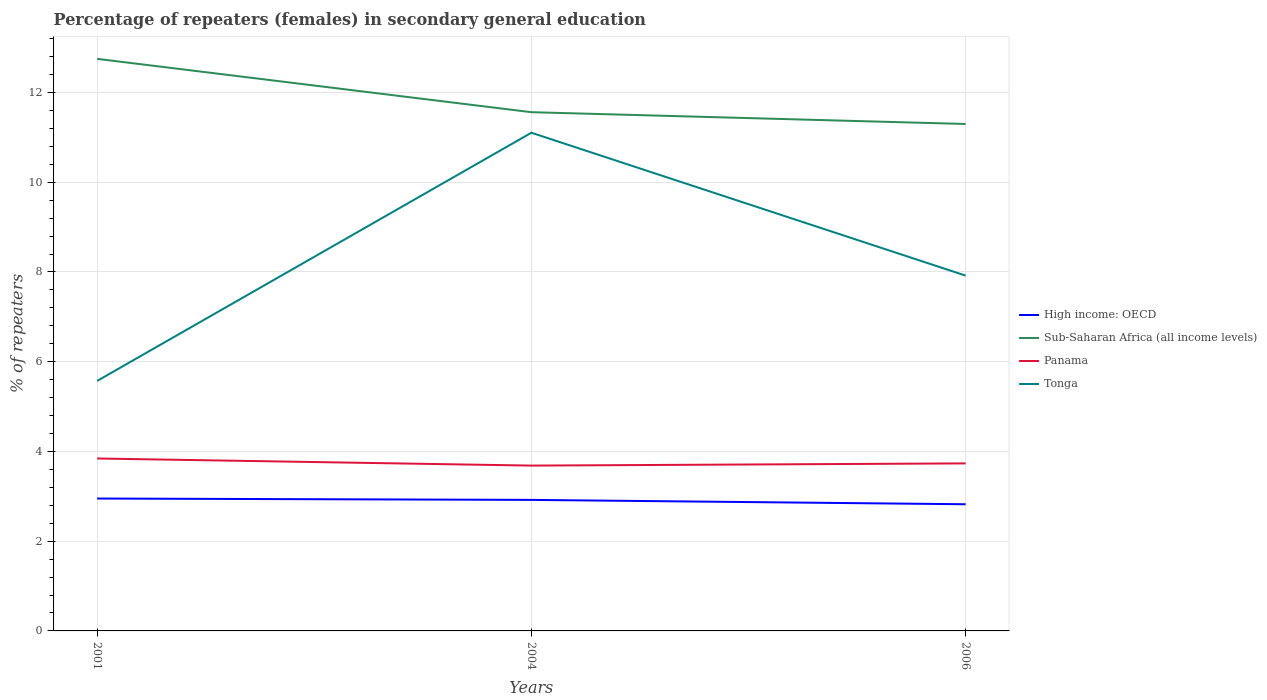How many different coloured lines are there?
Your answer should be very brief. 4. Across all years, what is the maximum percentage of female repeaters in Panama?
Give a very brief answer. 3.68. What is the total percentage of female repeaters in Panama in the graph?
Offer a terse response. -0.05. What is the difference between the highest and the second highest percentage of female repeaters in Panama?
Your answer should be compact. 0.16. What is the difference between the highest and the lowest percentage of female repeaters in High income: OECD?
Ensure brevity in your answer.  2. How many lines are there?
Provide a succinct answer. 4. What is the difference between two consecutive major ticks on the Y-axis?
Offer a terse response. 2. Are the values on the major ticks of Y-axis written in scientific E-notation?
Make the answer very short. No. Does the graph contain grids?
Your answer should be compact. Yes. How are the legend labels stacked?
Ensure brevity in your answer.  Vertical. What is the title of the graph?
Keep it short and to the point. Percentage of repeaters (females) in secondary general education. What is the label or title of the X-axis?
Offer a terse response. Years. What is the label or title of the Y-axis?
Offer a terse response. % of repeaters. What is the % of repeaters in High income: OECD in 2001?
Ensure brevity in your answer.  2.95. What is the % of repeaters in Sub-Saharan Africa (all income levels) in 2001?
Give a very brief answer. 12.75. What is the % of repeaters of Panama in 2001?
Your answer should be very brief. 3.84. What is the % of repeaters in Tonga in 2001?
Your answer should be compact. 5.57. What is the % of repeaters in High income: OECD in 2004?
Give a very brief answer. 2.92. What is the % of repeaters in Sub-Saharan Africa (all income levels) in 2004?
Ensure brevity in your answer.  11.56. What is the % of repeaters of Panama in 2004?
Provide a succinct answer. 3.68. What is the % of repeaters of Tonga in 2004?
Your answer should be very brief. 11.1. What is the % of repeaters of High income: OECD in 2006?
Make the answer very short. 2.82. What is the % of repeaters in Sub-Saharan Africa (all income levels) in 2006?
Provide a short and direct response. 11.3. What is the % of repeaters of Panama in 2006?
Provide a succinct answer. 3.73. What is the % of repeaters of Tonga in 2006?
Offer a very short reply. 7.92. Across all years, what is the maximum % of repeaters in High income: OECD?
Give a very brief answer. 2.95. Across all years, what is the maximum % of repeaters of Sub-Saharan Africa (all income levels)?
Make the answer very short. 12.75. Across all years, what is the maximum % of repeaters in Panama?
Provide a succinct answer. 3.84. Across all years, what is the maximum % of repeaters of Tonga?
Provide a short and direct response. 11.1. Across all years, what is the minimum % of repeaters of High income: OECD?
Offer a terse response. 2.82. Across all years, what is the minimum % of repeaters in Sub-Saharan Africa (all income levels)?
Ensure brevity in your answer.  11.3. Across all years, what is the minimum % of repeaters of Panama?
Your response must be concise. 3.68. Across all years, what is the minimum % of repeaters of Tonga?
Provide a succinct answer. 5.57. What is the total % of repeaters in High income: OECD in the graph?
Offer a terse response. 8.69. What is the total % of repeaters of Sub-Saharan Africa (all income levels) in the graph?
Make the answer very short. 35.61. What is the total % of repeaters of Panama in the graph?
Offer a terse response. 11.26. What is the total % of repeaters of Tonga in the graph?
Offer a very short reply. 24.6. What is the difference between the % of repeaters of High income: OECD in 2001 and that in 2004?
Offer a very short reply. 0.03. What is the difference between the % of repeaters in Sub-Saharan Africa (all income levels) in 2001 and that in 2004?
Ensure brevity in your answer.  1.19. What is the difference between the % of repeaters in Panama in 2001 and that in 2004?
Make the answer very short. 0.16. What is the difference between the % of repeaters in Tonga in 2001 and that in 2004?
Your answer should be compact. -5.53. What is the difference between the % of repeaters of High income: OECD in 2001 and that in 2006?
Offer a terse response. 0.13. What is the difference between the % of repeaters of Sub-Saharan Africa (all income levels) in 2001 and that in 2006?
Give a very brief answer. 1.45. What is the difference between the % of repeaters in Panama in 2001 and that in 2006?
Your answer should be compact. 0.11. What is the difference between the % of repeaters in Tonga in 2001 and that in 2006?
Provide a short and direct response. -2.35. What is the difference between the % of repeaters in High income: OECD in 2004 and that in 2006?
Offer a very short reply. 0.1. What is the difference between the % of repeaters of Sub-Saharan Africa (all income levels) in 2004 and that in 2006?
Provide a succinct answer. 0.26. What is the difference between the % of repeaters in Panama in 2004 and that in 2006?
Your response must be concise. -0.05. What is the difference between the % of repeaters of Tonga in 2004 and that in 2006?
Your answer should be very brief. 3.19. What is the difference between the % of repeaters of High income: OECD in 2001 and the % of repeaters of Sub-Saharan Africa (all income levels) in 2004?
Your answer should be very brief. -8.61. What is the difference between the % of repeaters in High income: OECD in 2001 and the % of repeaters in Panama in 2004?
Offer a very short reply. -0.73. What is the difference between the % of repeaters in High income: OECD in 2001 and the % of repeaters in Tonga in 2004?
Your response must be concise. -8.15. What is the difference between the % of repeaters of Sub-Saharan Africa (all income levels) in 2001 and the % of repeaters of Panama in 2004?
Ensure brevity in your answer.  9.07. What is the difference between the % of repeaters of Sub-Saharan Africa (all income levels) in 2001 and the % of repeaters of Tonga in 2004?
Offer a terse response. 1.65. What is the difference between the % of repeaters in Panama in 2001 and the % of repeaters in Tonga in 2004?
Keep it short and to the point. -7.26. What is the difference between the % of repeaters in High income: OECD in 2001 and the % of repeaters in Sub-Saharan Africa (all income levels) in 2006?
Offer a terse response. -8.35. What is the difference between the % of repeaters in High income: OECD in 2001 and the % of repeaters in Panama in 2006?
Provide a short and direct response. -0.78. What is the difference between the % of repeaters of High income: OECD in 2001 and the % of repeaters of Tonga in 2006?
Keep it short and to the point. -4.97. What is the difference between the % of repeaters of Sub-Saharan Africa (all income levels) in 2001 and the % of repeaters of Panama in 2006?
Provide a short and direct response. 9.02. What is the difference between the % of repeaters of Sub-Saharan Africa (all income levels) in 2001 and the % of repeaters of Tonga in 2006?
Make the answer very short. 4.83. What is the difference between the % of repeaters of Panama in 2001 and the % of repeaters of Tonga in 2006?
Offer a very short reply. -4.08. What is the difference between the % of repeaters of High income: OECD in 2004 and the % of repeaters of Sub-Saharan Africa (all income levels) in 2006?
Your response must be concise. -8.38. What is the difference between the % of repeaters of High income: OECD in 2004 and the % of repeaters of Panama in 2006?
Your answer should be compact. -0.81. What is the difference between the % of repeaters of High income: OECD in 2004 and the % of repeaters of Tonga in 2006?
Make the answer very short. -5. What is the difference between the % of repeaters of Sub-Saharan Africa (all income levels) in 2004 and the % of repeaters of Panama in 2006?
Offer a very short reply. 7.83. What is the difference between the % of repeaters in Sub-Saharan Africa (all income levels) in 2004 and the % of repeaters in Tonga in 2006?
Keep it short and to the point. 3.64. What is the difference between the % of repeaters in Panama in 2004 and the % of repeaters in Tonga in 2006?
Your answer should be very brief. -4.23. What is the average % of repeaters in High income: OECD per year?
Your response must be concise. 2.9. What is the average % of repeaters of Sub-Saharan Africa (all income levels) per year?
Ensure brevity in your answer.  11.87. What is the average % of repeaters of Panama per year?
Your answer should be very brief. 3.75. What is the average % of repeaters in Tonga per year?
Provide a succinct answer. 8.2. In the year 2001, what is the difference between the % of repeaters of High income: OECD and % of repeaters of Sub-Saharan Africa (all income levels)?
Provide a short and direct response. -9.8. In the year 2001, what is the difference between the % of repeaters of High income: OECD and % of repeaters of Panama?
Your answer should be compact. -0.89. In the year 2001, what is the difference between the % of repeaters in High income: OECD and % of repeaters in Tonga?
Make the answer very short. -2.62. In the year 2001, what is the difference between the % of repeaters in Sub-Saharan Africa (all income levels) and % of repeaters in Panama?
Make the answer very short. 8.91. In the year 2001, what is the difference between the % of repeaters in Sub-Saharan Africa (all income levels) and % of repeaters in Tonga?
Your answer should be compact. 7.18. In the year 2001, what is the difference between the % of repeaters of Panama and % of repeaters of Tonga?
Keep it short and to the point. -1.73. In the year 2004, what is the difference between the % of repeaters of High income: OECD and % of repeaters of Sub-Saharan Africa (all income levels)?
Keep it short and to the point. -8.64. In the year 2004, what is the difference between the % of repeaters in High income: OECD and % of repeaters in Panama?
Keep it short and to the point. -0.76. In the year 2004, what is the difference between the % of repeaters of High income: OECD and % of repeaters of Tonga?
Offer a terse response. -8.18. In the year 2004, what is the difference between the % of repeaters of Sub-Saharan Africa (all income levels) and % of repeaters of Panama?
Offer a very short reply. 7.88. In the year 2004, what is the difference between the % of repeaters of Sub-Saharan Africa (all income levels) and % of repeaters of Tonga?
Your answer should be compact. 0.46. In the year 2004, what is the difference between the % of repeaters of Panama and % of repeaters of Tonga?
Your answer should be very brief. -7.42. In the year 2006, what is the difference between the % of repeaters in High income: OECD and % of repeaters in Sub-Saharan Africa (all income levels)?
Your answer should be very brief. -8.48. In the year 2006, what is the difference between the % of repeaters in High income: OECD and % of repeaters in Panama?
Keep it short and to the point. -0.91. In the year 2006, what is the difference between the % of repeaters of High income: OECD and % of repeaters of Tonga?
Offer a terse response. -5.1. In the year 2006, what is the difference between the % of repeaters in Sub-Saharan Africa (all income levels) and % of repeaters in Panama?
Keep it short and to the point. 7.57. In the year 2006, what is the difference between the % of repeaters in Sub-Saharan Africa (all income levels) and % of repeaters in Tonga?
Make the answer very short. 3.38. In the year 2006, what is the difference between the % of repeaters of Panama and % of repeaters of Tonga?
Your response must be concise. -4.19. What is the ratio of the % of repeaters of High income: OECD in 2001 to that in 2004?
Your answer should be very brief. 1.01. What is the ratio of the % of repeaters of Sub-Saharan Africa (all income levels) in 2001 to that in 2004?
Your answer should be compact. 1.1. What is the ratio of the % of repeaters in Panama in 2001 to that in 2004?
Offer a terse response. 1.04. What is the ratio of the % of repeaters in Tonga in 2001 to that in 2004?
Your response must be concise. 0.5. What is the ratio of the % of repeaters of High income: OECD in 2001 to that in 2006?
Make the answer very short. 1.05. What is the ratio of the % of repeaters of Sub-Saharan Africa (all income levels) in 2001 to that in 2006?
Provide a succinct answer. 1.13. What is the ratio of the % of repeaters of Panama in 2001 to that in 2006?
Keep it short and to the point. 1.03. What is the ratio of the % of repeaters of Tonga in 2001 to that in 2006?
Make the answer very short. 0.7. What is the ratio of the % of repeaters in High income: OECD in 2004 to that in 2006?
Offer a terse response. 1.03. What is the ratio of the % of repeaters of Sub-Saharan Africa (all income levels) in 2004 to that in 2006?
Provide a short and direct response. 1.02. What is the ratio of the % of repeaters in Panama in 2004 to that in 2006?
Your response must be concise. 0.99. What is the ratio of the % of repeaters of Tonga in 2004 to that in 2006?
Keep it short and to the point. 1.4. What is the difference between the highest and the second highest % of repeaters in High income: OECD?
Your response must be concise. 0.03. What is the difference between the highest and the second highest % of repeaters in Sub-Saharan Africa (all income levels)?
Your answer should be very brief. 1.19. What is the difference between the highest and the second highest % of repeaters of Panama?
Give a very brief answer. 0.11. What is the difference between the highest and the second highest % of repeaters in Tonga?
Make the answer very short. 3.19. What is the difference between the highest and the lowest % of repeaters in High income: OECD?
Provide a succinct answer. 0.13. What is the difference between the highest and the lowest % of repeaters in Sub-Saharan Africa (all income levels)?
Your response must be concise. 1.45. What is the difference between the highest and the lowest % of repeaters in Panama?
Give a very brief answer. 0.16. What is the difference between the highest and the lowest % of repeaters in Tonga?
Your response must be concise. 5.53. 